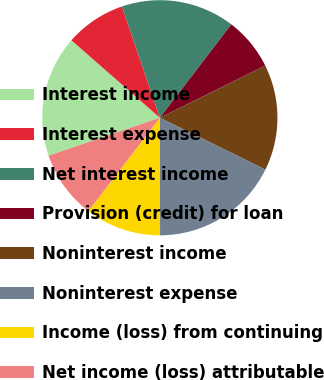Convert chart to OTSL. <chart><loc_0><loc_0><loc_500><loc_500><pie_chart><fcel>Interest income<fcel>Interest expense<fcel>Net interest income<fcel>Provision (credit) for loan<fcel>Noninterest income<fcel>Noninterest expense<fcel>Income (loss) from continuing<fcel>Net income (loss) attributable<nl><fcel>16.67%<fcel>8.33%<fcel>15.62%<fcel>7.29%<fcel>14.58%<fcel>17.71%<fcel>10.42%<fcel>9.38%<nl></chart> 